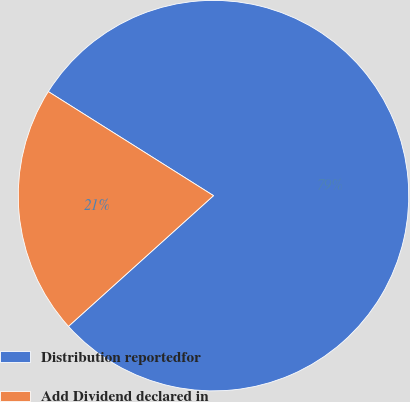<chart> <loc_0><loc_0><loc_500><loc_500><pie_chart><fcel>Distribution reportedfor<fcel>Add Dividend declared in<nl><fcel>79.38%<fcel>20.62%<nl></chart> 